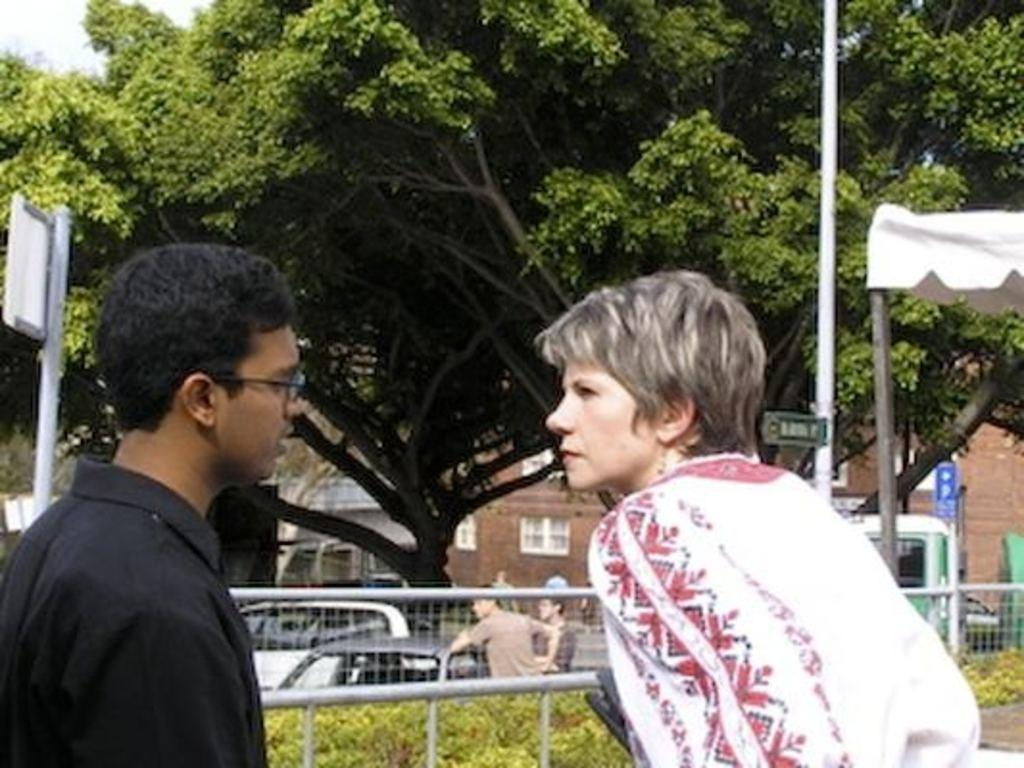How many people are in the image? There are two people in the image. Where are the people located in the image? The people are on a path in the image. What is behind the people in the image? There is a fence behind the people in the image. What type of vegetation can be seen in the image? Plants are visible in the image. What else can be seen in the image besides the people and plants? Vehicles, poles with directional boards, buildings, trees, and the sky are visible in the image. What time of day is it according to the hour on the toy in the image? There is no toy present in the image, so it is not possible to determine the time of day based on an hour from a toy. 